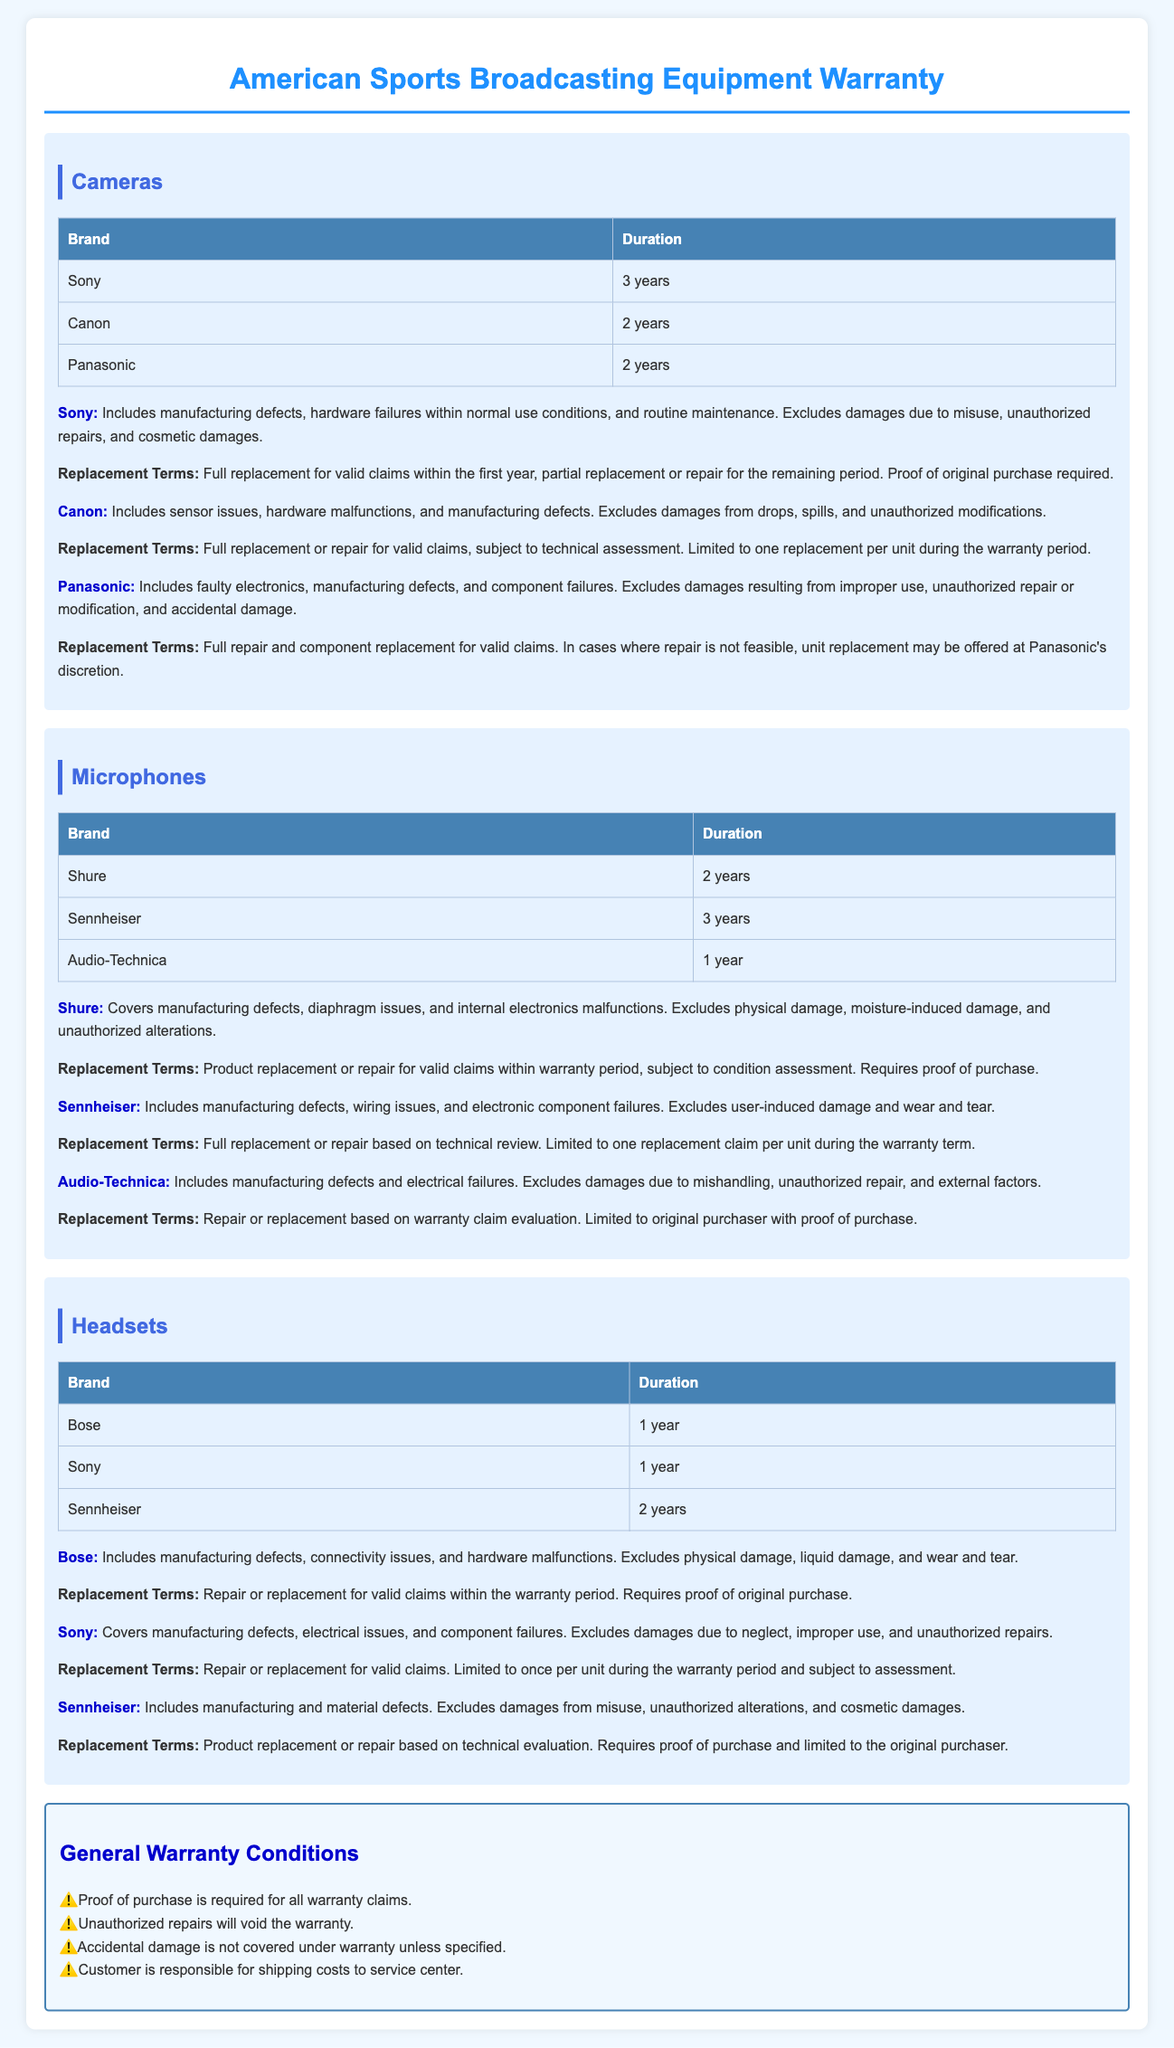What is the warranty duration for Sony cameras? The warranty duration for Sony cameras is specified in the table under the "Cameras" section.
Answer: 3 years Which brand of microphone has the longest warranty period? The longest warranty period for microphones can be found in the table under the "Microphones" section.
Answer: Sennheiser What is excluded from warranty coverage for Audio-Technica microphones? The exclusions for Audio-Technica microphones are detailed in the specific brand information.
Answer: Damages due to mishandling, unauthorized repair, and external factors How many replacements can be claimed for Canon cameras during the warranty period? The replacement terms for Canon cameras specify the allowance for claims.
Answer: One replacement Who is responsible for shipping costs to the service center? The general warranty conditions outline the responsibility for shipping costs.
Answer: Customer What types of damages are not covered by Bose headsets warranty? The brand information for Bose headsets specifies the types of damages not covered.
Answer: Physical damage, liquid damage, and wear and tear What must be provided for all warranty claims? The general warranty conditions state the requirement necessary for warranty claims.
Answer: Proof of purchase What is the warranty coverage for Panasonic cameras? The warranty coverage details for Panasonic cameras are found in the specific brand information.
Answer: Faulty electronics, manufacturing defects, and component failures 